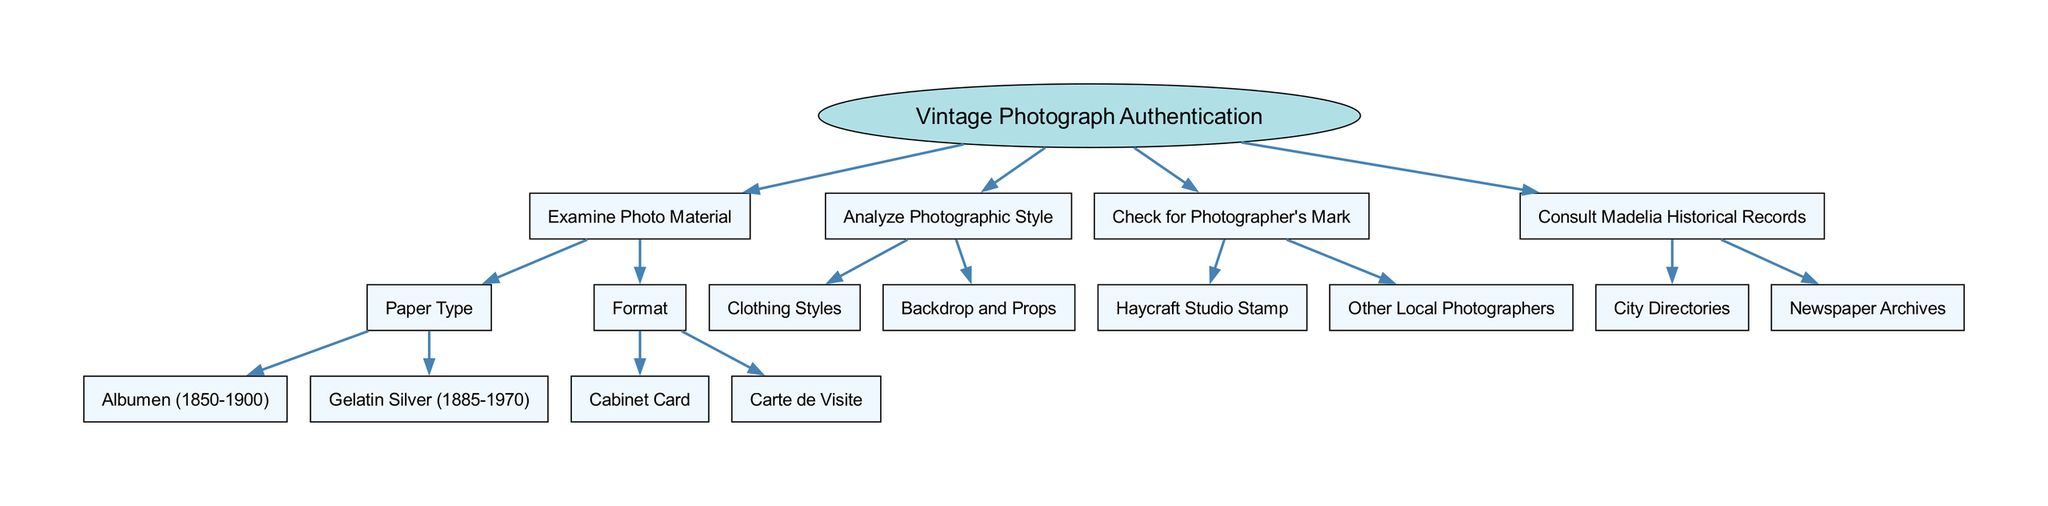What is the root node of the diagram? The root node is the starting point of the decision process, and it is labeled "Vintage Photograph Authentication." This is explicitly stated in the diagram as the initial point of the flow.
Answer: Vintage Photograph Authentication How many main processes are identified for authenticating vintage photographs? By examining the diagram, four distinct main processes are present: "Examine Photo Material," "Analyze Photographic Style," "Check for Photographer's Mark," and "Consult Madelia Historical Records." Each of these can be counted directly from the nodes under the root.
Answer: 4 What are the two types of paper identified in the "Examine Photo Material" process? In the "Examine Photo Material" section, two specific types of paper are listed: "Albumen (1850-1900)" and "Gelatin Silver (1885-1970)." This information can be found under the node related to paper type.
Answer: Albumen (1850-1900), Gelatin Silver (1885-1970) Which process involves checking for the "Haycraft Studio Stamp"? The process that involves checking for the "Haycraft Studio Stamp" is "Check for Photographer's Mark." This can be traced from the relationship of nodes where this detail is a child node of the corresponding parent node.
Answer: Check for Photographer's Mark What types of historical records can be consulted according to the diagram? The diagram specifies two types of historical records that can be consulted: "City Directories" and "Newspaper Archives." These are direct children of the "Consult Madelia Historical Records" node, allowing for straightforward identification.
Answer: City Directories, Newspaper Archives What is analyzed alongside "Clothing Styles" in the "Analyze Photographic Style" process? In addition to "Clothing Styles," the other aspect analyzed in the "Analyze Photographic Style" process is "Backdrop and Props." This is another child node that shares the same parent, indicating a composite analysis in this area.
Answer: Backdrop and Props What node comes directly after examining "Format"? After examining "Format," the following nodes to review are "Cabinet Card" and "Carte de Visite," which are the child nodes stemming directly from the "Format" node, thereby confirming their sequential position.
Answer: Cabinet Card, Carte de Visite Which node represents a method of verifying authenticity through local context? The node representing a method of verifying authenticity through local context is "Consult Madelia Historical Records." This shows a broader connection with the history and context surrounding the photographs, aligning well with local historical inquiries.
Answer: Consult Madelia Historical Records 